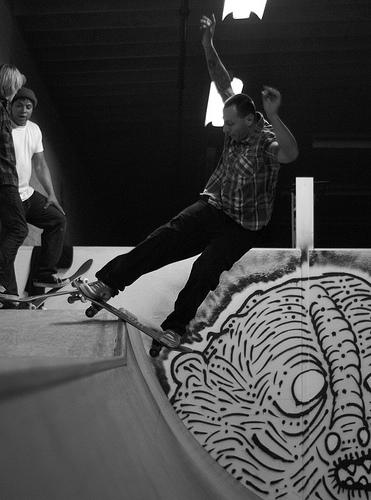What type of print is the man raising his hands wearing on his shirt?

Choices:
A) animal
B) psychedelic
C) plaid
D) circular plaid 